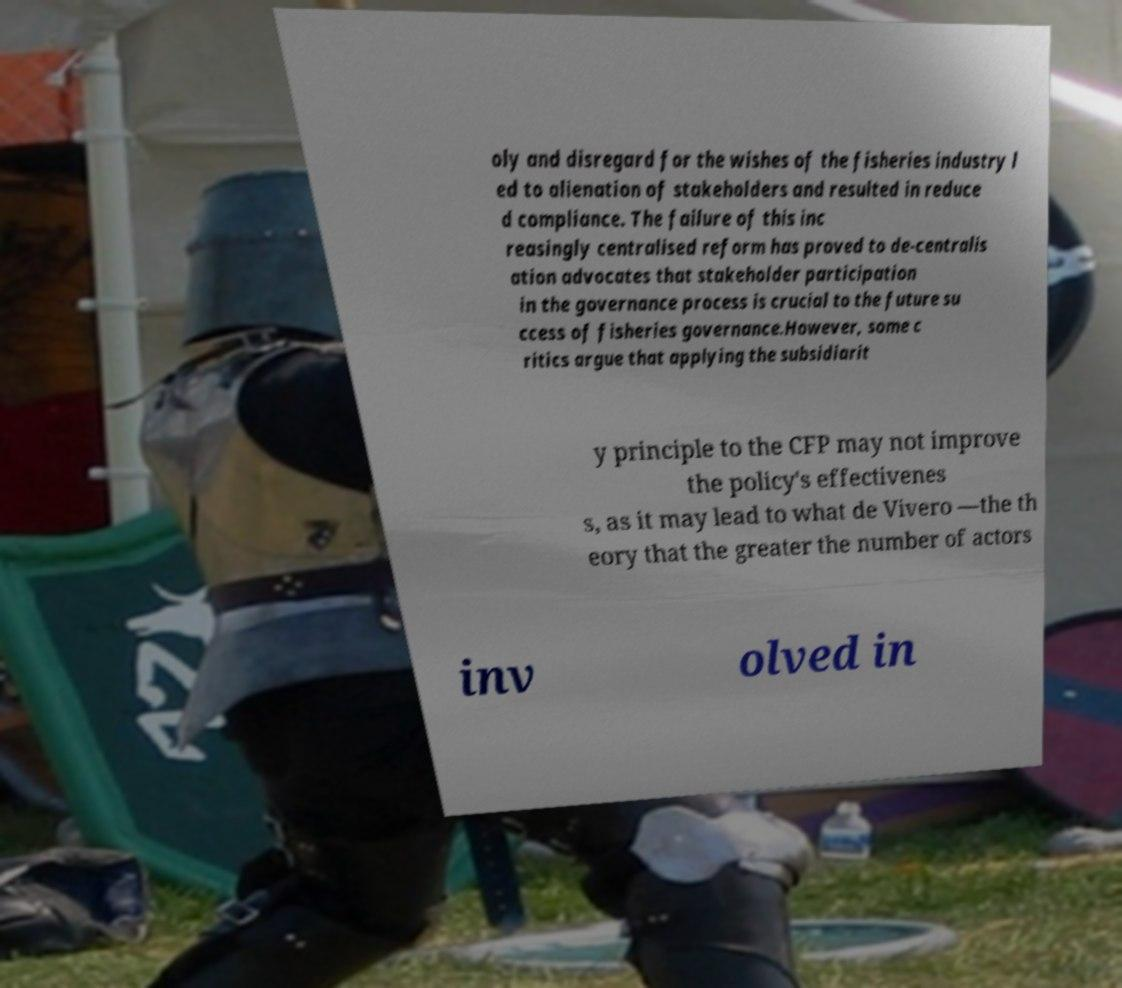Can you accurately transcribe the text from the provided image for me? oly and disregard for the wishes of the fisheries industry l ed to alienation of stakeholders and resulted in reduce d compliance. The failure of this inc reasingly centralised reform has proved to de-centralis ation advocates that stakeholder participation in the governance process is crucial to the future su ccess of fisheries governance.However, some c ritics argue that applying the subsidiarit y principle to the CFP may not improve the policy's effectivenes s, as it may lead to what de Vivero —the th eory that the greater the number of actors inv olved in 